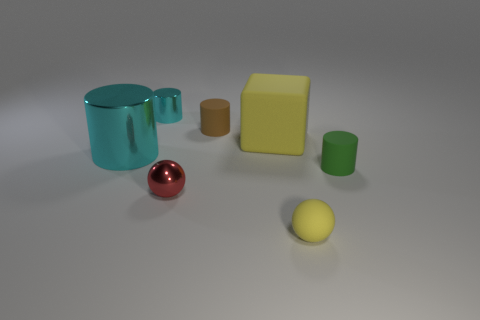There is a brown rubber cylinder; what number of small brown objects are behind it?
Ensure brevity in your answer.  0. Is there a blue metal ball of the same size as the red metal sphere?
Give a very brief answer. No. Are there any other big shiny things that have the same color as the big metal thing?
Ensure brevity in your answer.  No. Is there any other thing that has the same size as the green rubber thing?
Your answer should be very brief. Yes. How many large matte things have the same color as the tiny shiny sphere?
Your answer should be very brief. 0. There is a rubber cube; is its color the same as the tiny matte thing that is in front of the red shiny object?
Offer a very short reply. Yes. How many things are either large cyan things or small rubber objects behind the tiny red metal object?
Give a very brief answer. 3. What size is the metal thing that is on the left side of the small metallic object that is behind the small green rubber cylinder?
Your answer should be very brief. Large. Are there the same number of green cylinders that are behind the green object and large matte objects that are right of the big cube?
Give a very brief answer. Yes. There is a ball behind the tiny yellow rubber thing; is there a red metal ball behind it?
Your response must be concise. No. 